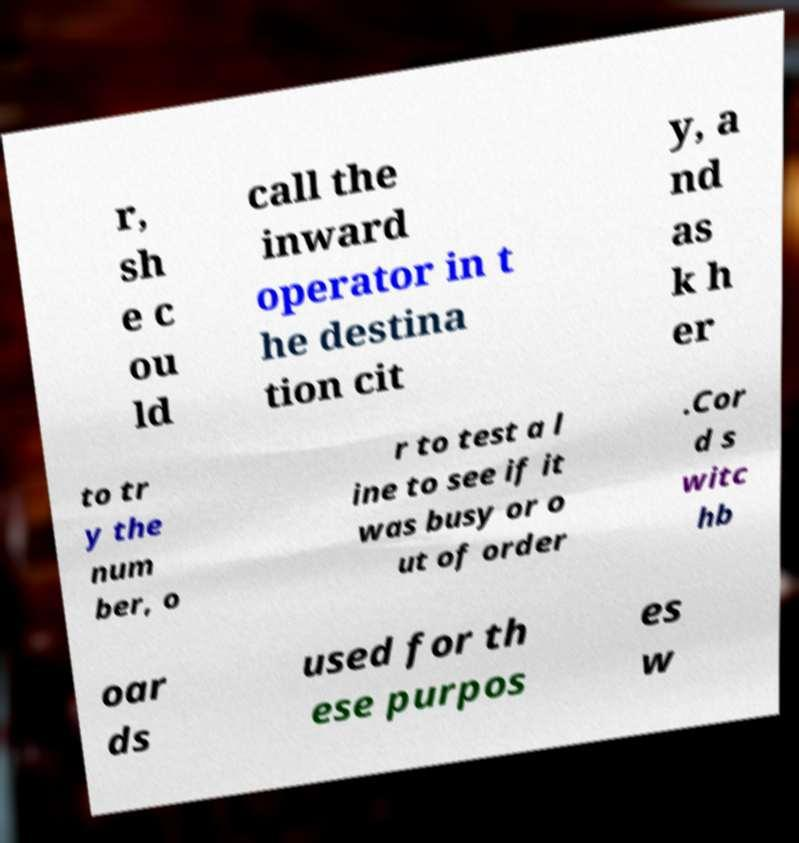I need the written content from this picture converted into text. Can you do that? r, sh e c ou ld call the inward operator in t he destina tion cit y, a nd as k h er to tr y the num ber, o r to test a l ine to see if it was busy or o ut of order .Cor d s witc hb oar ds used for th ese purpos es w 